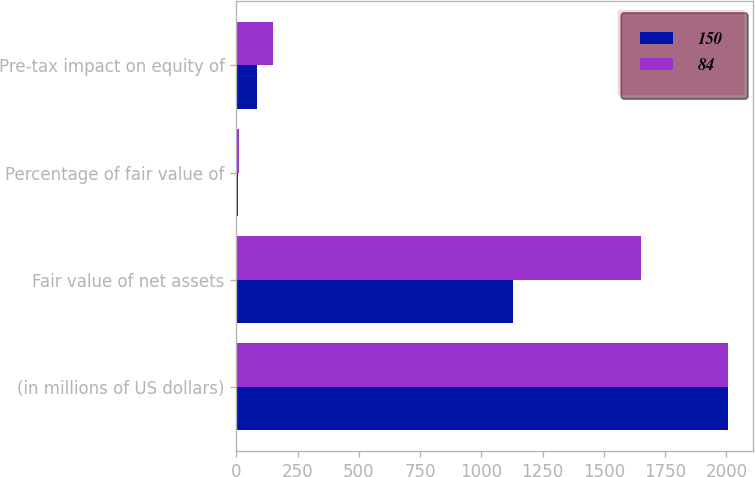Convert chart. <chart><loc_0><loc_0><loc_500><loc_500><stacked_bar_chart><ecel><fcel>(in millions of US dollars)<fcel>Fair value of net assets<fcel>Percentage of fair value of<fcel>Pre-tax impact on equity of<nl><fcel>150<fcel>2008<fcel>1127<fcel>7.8<fcel>84<nl><fcel>84<fcel>2007<fcel>1651<fcel>9.9<fcel>150<nl></chart> 